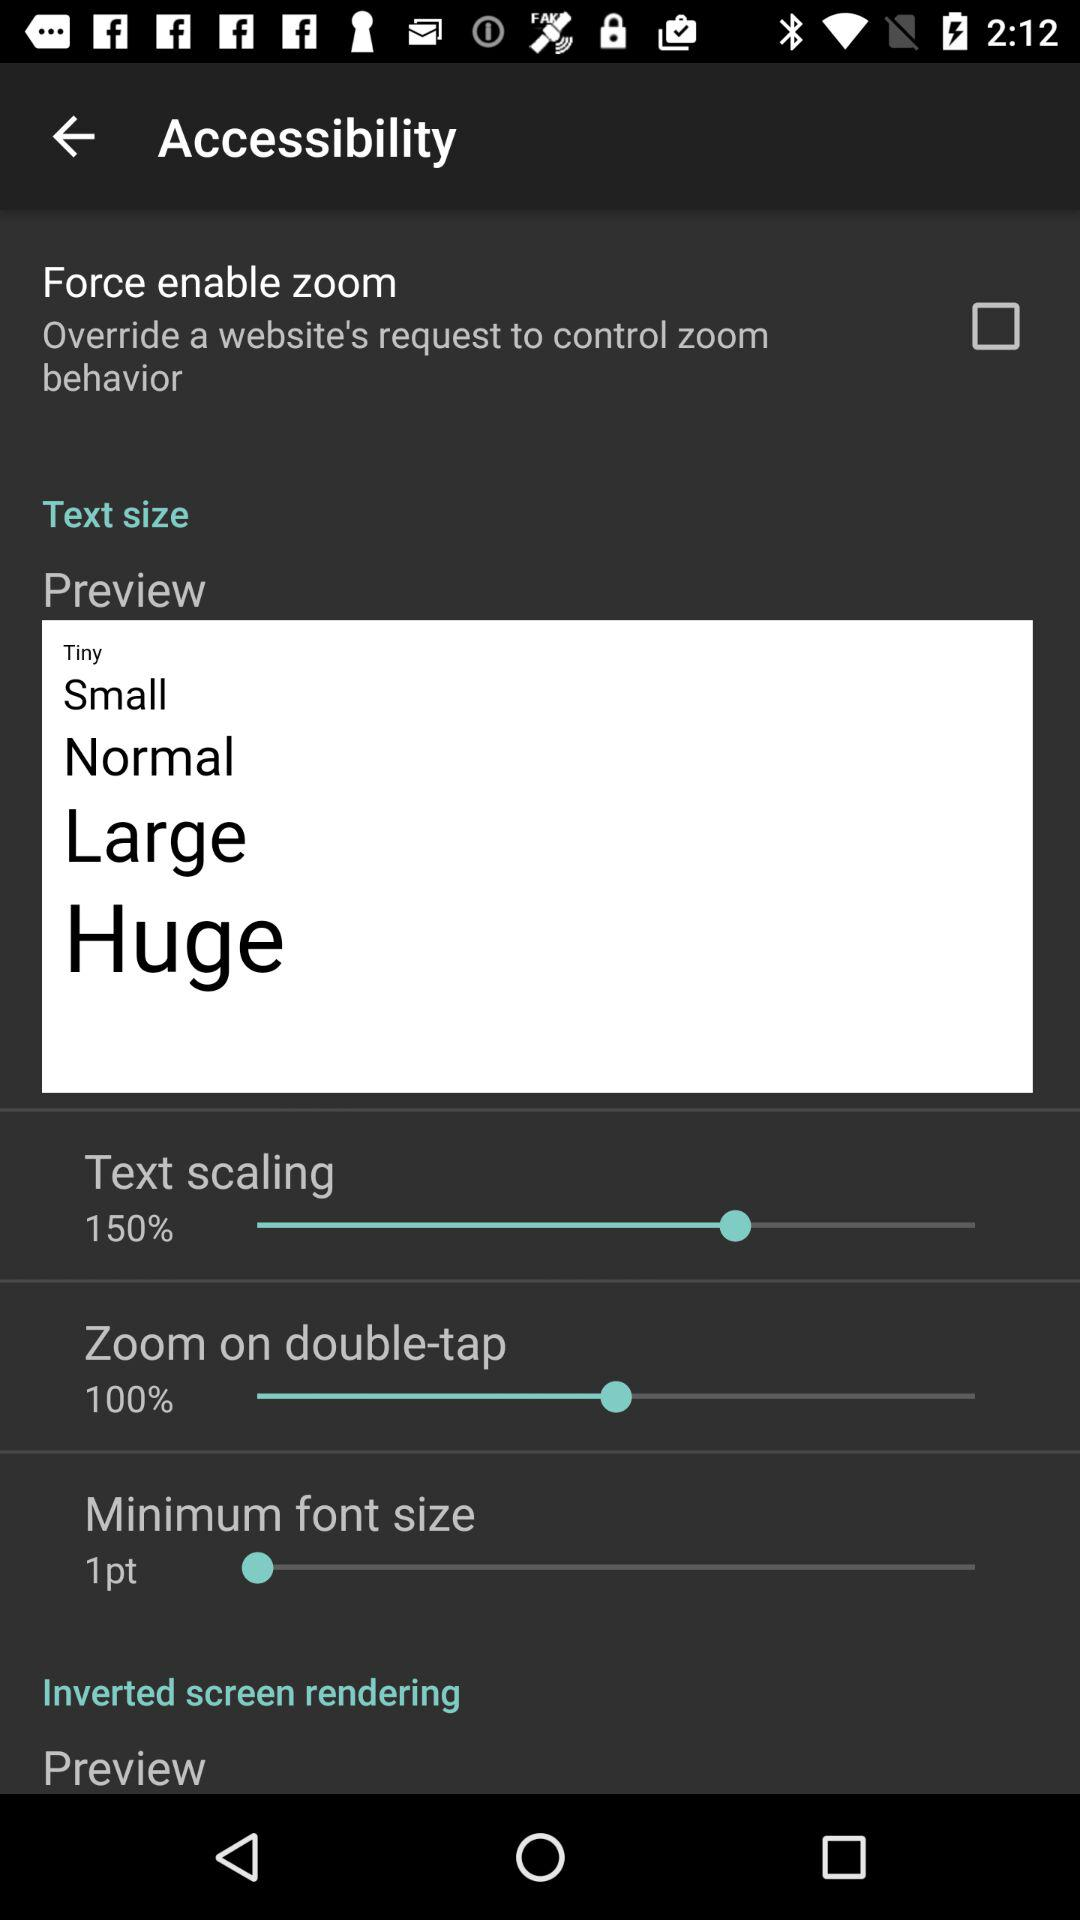What is the percentage for "Zoom on double-tap"?
Answer the question using a single word or phrase. It's 100 percent. 